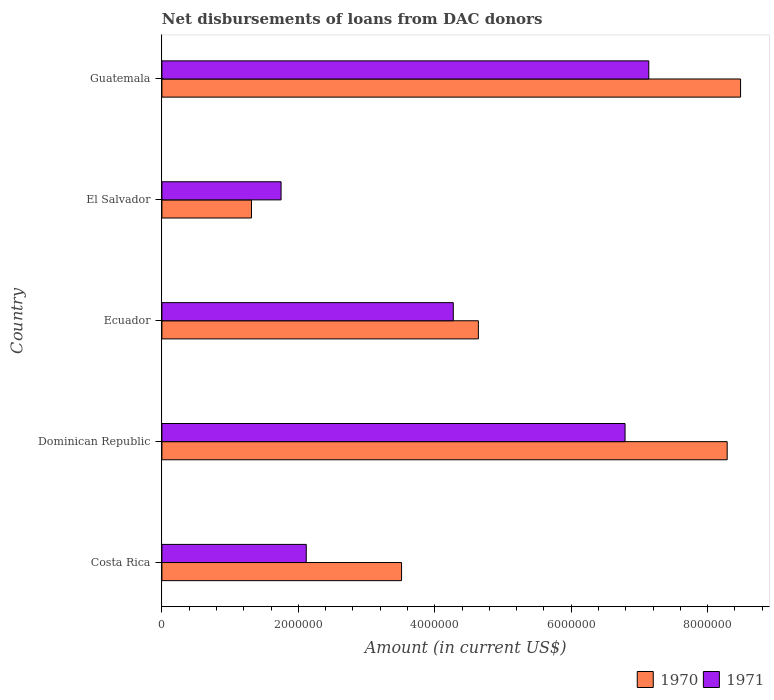Are the number of bars per tick equal to the number of legend labels?
Provide a short and direct response. Yes. How many bars are there on the 3rd tick from the top?
Keep it short and to the point. 2. What is the label of the 1st group of bars from the top?
Provide a succinct answer. Guatemala. What is the amount of loans disbursed in 1971 in Costa Rica?
Make the answer very short. 2.12e+06. Across all countries, what is the maximum amount of loans disbursed in 1971?
Offer a terse response. 7.14e+06. Across all countries, what is the minimum amount of loans disbursed in 1971?
Your answer should be very brief. 1.75e+06. In which country was the amount of loans disbursed in 1970 maximum?
Provide a succinct answer. Guatemala. In which country was the amount of loans disbursed in 1971 minimum?
Keep it short and to the point. El Salvador. What is the total amount of loans disbursed in 1971 in the graph?
Make the answer very short. 2.21e+07. What is the difference between the amount of loans disbursed in 1970 in El Salvador and that in Guatemala?
Your answer should be compact. -7.17e+06. What is the difference between the amount of loans disbursed in 1971 in Guatemala and the amount of loans disbursed in 1970 in Dominican Republic?
Provide a short and direct response. -1.15e+06. What is the average amount of loans disbursed in 1971 per country?
Give a very brief answer. 4.41e+06. What is the difference between the amount of loans disbursed in 1970 and amount of loans disbursed in 1971 in Dominican Republic?
Ensure brevity in your answer.  1.50e+06. What is the ratio of the amount of loans disbursed in 1971 in Ecuador to that in Guatemala?
Offer a terse response. 0.6. Is the amount of loans disbursed in 1970 in Ecuador less than that in El Salvador?
Provide a succinct answer. No. Is the difference between the amount of loans disbursed in 1970 in Dominican Republic and Ecuador greater than the difference between the amount of loans disbursed in 1971 in Dominican Republic and Ecuador?
Offer a terse response. Yes. What is the difference between the highest and the second highest amount of loans disbursed in 1970?
Provide a succinct answer. 1.96e+05. What is the difference between the highest and the lowest amount of loans disbursed in 1970?
Your answer should be compact. 7.17e+06. In how many countries, is the amount of loans disbursed in 1971 greater than the average amount of loans disbursed in 1971 taken over all countries?
Provide a short and direct response. 2. Is the sum of the amount of loans disbursed in 1971 in Ecuador and El Salvador greater than the maximum amount of loans disbursed in 1970 across all countries?
Ensure brevity in your answer.  No. What does the 2nd bar from the bottom in Guatemala represents?
Your answer should be compact. 1971. Are all the bars in the graph horizontal?
Your response must be concise. Yes. How many countries are there in the graph?
Your response must be concise. 5. What is the difference between two consecutive major ticks on the X-axis?
Ensure brevity in your answer.  2.00e+06. Does the graph contain any zero values?
Provide a short and direct response. No. Does the graph contain grids?
Provide a short and direct response. No. How many legend labels are there?
Your answer should be compact. 2. How are the legend labels stacked?
Your answer should be compact. Horizontal. What is the title of the graph?
Provide a short and direct response. Net disbursements of loans from DAC donors. What is the label or title of the Y-axis?
Your answer should be compact. Country. What is the Amount (in current US$) of 1970 in Costa Rica?
Your answer should be compact. 3.51e+06. What is the Amount (in current US$) in 1971 in Costa Rica?
Your answer should be very brief. 2.12e+06. What is the Amount (in current US$) of 1970 in Dominican Republic?
Your response must be concise. 8.29e+06. What is the Amount (in current US$) in 1971 in Dominican Republic?
Provide a short and direct response. 6.79e+06. What is the Amount (in current US$) in 1970 in Ecuador?
Provide a short and direct response. 4.64e+06. What is the Amount (in current US$) in 1971 in Ecuador?
Make the answer very short. 4.27e+06. What is the Amount (in current US$) in 1970 in El Salvador?
Offer a terse response. 1.31e+06. What is the Amount (in current US$) of 1971 in El Salvador?
Keep it short and to the point. 1.75e+06. What is the Amount (in current US$) of 1970 in Guatemala?
Offer a very short reply. 8.48e+06. What is the Amount (in current US$) in 1971 in Guatemala?
Your response must be concise. 7.14e+06. Across all countries, what is the maximum Amount (in current US$) in 1970?
Ensure brevity in your answer.  8.48e+06. Across all countries, what is the maximum Amount (in current US$) in 1971?
Your response must be concise. 7.14e+06. Across all countries, what is the minimum Amount (in current US$) of 1970?
Ensure brevity in your answer.  1.31e+06. Across all countries, what is the minimum Amount (in current US$) of 1971?
Give a very brief answer. 1.75e+06. What is the total Amount (in current US$) of 1970 in the graph?
Your response must be concise. 2.62e+07. What is the total Amount (in current US$) of 1971 in the graph?
Keep it short and to the point. 2.21e+07. What is the difference between the Amount (in current US$) of 1970 in Costa Rica and that in Dominican Republic?
Your response must be concise. -4.77e+06. What is the difference between the Amount (in current US$) of 1971 in Costa Rica and that in Dominican Republic?
Make the answer very short. -4.67e+06. What is the difference between the Amount (in current US$) in 1970 in Costa Rica and that in Ecuador?
Give a very brief answer. -1.13e+06. What is the difference between the Amount (in current US$) of 1971 in Costa Rica and that in Ecuador?
Give a very brief answer. -2.16e+06. What is the difference between the Amount (in current US$) of 1970 in Costa Rica and that in El Salvador?
Your answer should be very brief. 2.20e+06. What is the difference between the Amount (in current US$) in 1971 in Costa Rica and that in El Salvador?
Your response must be concise. 3.69e+05. What is the difference between the Amount (in current US$) in 1970 in Costa Rica and that in Guatemala?
Ensure brevity in your answer.  -4.97e+06. What is the difference between the Amount (in current US$) in 1971 in Costa Rica and that in Guatemala?
Your answer should be compact. -5.02e+06. What is the difference between the Amount (in current US$) of 1970 in Dominican Republic and that in Ecuador?
Your response must be concise. 3.65e+06. What is the difference between the Amount (in current US$) in 1971 in Dominican Republic and that in Ecuador?
Your answer should be very brief. 2.52e+06. What is the difference between the Amount (in current US$) in 1970 in Dominican Republic and that in El Salvador?
Offer a very short reply. 6.97e+06. What is the difference between the Amount (in current US$) of 1971 in Dominican Republic and that in El Salvador?
Offer a very short reply. 5.04e+06. What is the difference between the Amount (in current US$) of 1970 in Dominican Republic and that in Guatemala?
Give a very brief answer. -1.96e+05. What is the difference between the Amount (in current US$) of 1971 in Dominican Republic and that in Guatemala?
Provide a succinct answer. -3.48e+05. What is the difference between the Amount (in current US$) in 1970 in Ecuador and that in El Salvador?
Offer a terse response. 3.33e+06. What is the difference between the Amount (in current US$) of 1971 in Ecuador and that in El Salvador?
Provide a short and direct response. 2.52e+06. What is the difference between the Amount (in current US$) of 1970 in Ecuador and that in Guatemala?
Offer a very short reply. -3.84e+06. What is the difference between the Amount (in current US$) in 1971 in Ecuador and that in Guatemala?
Provide a short and direct response. -2.87e+06. What is the difference between the Amount (in current US$) in 1970 in El Salvador and that in Guatemala?
Your answer should be compact. -7.17e+06. What is the difference between the Amount (in current US$) of 1971 in El Salvador and that in Guatemala?
Provide a succinct answer. -5.39e+06. What is the difference between the Amount (in current US$) of 1970 in Costa Rica and the Amount (in current US$) of 1971 in Dominican Republic?
Your answer should be very brief. -3.28e+06. What is the difference between the Amount (in current US$) in 1970 in Costa Rica and the Amount (in current US$) in 1971 in Ecuador?
Keep it short and to the point. -7.58e+05. What is the difference between the Amount (in current US$) of 1970 in Costa Rica and the Amount (in current US$) of 1971 in El Salvador?
Provide a succinct answer. 1.77e+06. What is the difference between the Amount (in current US$) in 1970 in Costa Rica and the Amount (in current US$) in 1971 in Guatemala?
Offer a very short reply. -3.62e+06. What is the difference between the Amount (in current US$) of 1970 in Dominican Republic and the Amount (in current US$) of 1971 in Ecuador?
Your answer should be very brief. 4.02e+06. What is the difference between the Amount (in current US$) in 1970 in Dominican Republic and the Amount (in current US$) in 1971 in El Salvador?
Offer a very short reply. 6.54e+06. What is the difference between the Amount (in current US$) of 1970 in Dominican Republic and the Amount (in current US$) of 1971 in Guatemala?
Provide a short and direct response. 1.15e+06. What is the difference between the Amount (in current US$) of 1970 in Ecuador and the Amount (in current US$) of 1971 in El Salvador?
Your answer should be very brief. 2.89e+06. What is the difference between the Amount (in current US$) in 1970 in Ecuador and the Amount (in current US$) in 1971 in Guatemala?
Ensure brevity in your answer.  -2.50e+06. What is the difference between the Amount (in current US$) in 1970 in El Salvador and the Amount (in current US$) in 1971 in Guatemala?
Offer a terse response. -5.82e+06. What is the average Amount (in current US$) of 1970 per country?
Provide a short and direct response. 5.25e+06. What is the average Amount (in current US$) in 1971 per country?
Provide a succinct answer. 4.41e+06. What is the difference between the Amount (in current US$) of 1970 and Amount (in current US$) of 1971 in Costa Rica?
Offer a terse response. 1.40e+06. What is the difference between the Amount (in current US$) of 1970 and Amount (in current US$) of 1971 in Dominican Republic?
Your response must be concise. 1.50e+06. What is the difference between the Amount (in current US$) of 1970 and Amount (in current US$) of 1971 in Ecuador?
Your answer should be very brief. 3.68e+05. What is the difference between the Amount (in current US$) in 1970 and Amount (in current US$) in 1971 in El Salvador?
Provide a succinct answer. -4.34e+05. What is the difference between the Amount (in current US$) of 1970 and Amount (in current US$) of 1971 in Guatemala?
Ensure brevity in your answer.  1.34e+06. What is the ratio of the Amount (in current US$) in 1970 in Costa Rica to that in Dominican Republic?
Offer a very short reply. 0.42. What is the ratio of the Amount (in current US$) of 1971 in Costa Rica to that in Dominican Republic?
Provide a short and direct response. 0.31. What is the ratio of the Amount (in current US$) of 1970 in Costa Rica to that in Ecuador?
Give a very brief answer. 0.76. What is the ratio of the Amount (in current US$) in 1971 in Costa Rica to that in Ecuador?
Offer a terse response. 0.5. What is the ratio of the Amount (in current US$) in 1970 in Costa Rica to that in El Salvador?
Ensure brevity in your answer.  2.68. What is the ratio of the Amount (in current US$) of 1971 in Costa Rica to that in El Salvador?
Your answer should be compact. 1.21. What is the ratio of the Amount (in current US$) of 1970 in Costa Rica to that in Guatemala?
Give a very brief answer. 0.41. What is the ratio of the Amount (in current US$) of 1971 in Costa Rica to that in Guatemala?
Offer a very short reply. 0.3. What is the ratio of the Amount (in current US$) in 1970 in Dominican Republic to that in Ecuador?
Ensure brevity in your answer.  1.79. What is the ratio of the Amount (in current US$) of 1971 in Dominican Republic to that in Ecuador?
Keep it short and to the point. 1.59. What is the ratio of the Amount (in current US$) of 1970 in Dominican Republic to that in El Salvador?
Make the answer very short. 6.31. What is the ratio of the Amount (in current US$) in 1971 in Dominican Republic to that in El Salvador?
Your answer should be compact. 3.89. What is the ratio of the Amount (in current US$) in 1970 in Dominican Republic to that in Guatemala?
Your answer should be compact. 0.98. What is the ratio of the Amount (in current US$) of 1971 in Dominican Republic to that in Guatemala?
Your answer should be very brief. 0.95. What is the ratio of the Amount (in current US$) of 1970 in Ecuador to that in El Salvador?
Your answer should be very brief. 3.53. What is the ratio of the Amount (in current US$) in 1971 in Ecuador to that in El Salvador?
Provide a succinct answer. 2.44. What is the ratio of the Amount (in current US$) of 1970 in Ecuador to that in Guatemala?
Your answer should be compact. 0.55. What is the ratio of the Amount (in current US$) in 1971 in Ecuador to that in Guatemala?
Give a very brief answer. 0.6. What is the ratio of the Amount (in current US$) of 1970 in El Salvador to that in Guatemala?
Provide a short and direct response. 0.15. What is the ratio of the Amount (in current US$) in 1971 in El Salvador to that in Guatemala?
Offer a terse response. 0.24. What is the difference between the highest and the second highest Amount (in current US$) in 1970?
Provide a succinct answer. 1.96e+05. What is the difference between the highest and the second highest Amount (in current US$) in 1971?
Make the answer very short. 3.48e+05. What is the difference between the highest and the lowest Amount (in current US$) in 1970?
Make the answer very short. 7.17e+06. What is the difference between the highest and the lowest Amount (in current US$) of 1971?
Provide a short and direct response. 5.39e+06. 